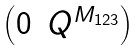<formula> <loc_0><loc_0><loc_500><loc_500>\begin{pmatrix} 0 & Q ^ { M _ { 1 2 3 } } \end{pmatrix}</formula> 